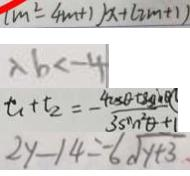Convert formula to latex. <formula><loc_0><loc_0><loc_500><loc_500>( m ^ { 2 } - 4 m + 1 ) x + ( 2 m + 1 ) 
 \lambda b < - 4 
 t _ { 1 } + t _ { 2 } = - \frac { 4 \cos \theta + 8 \sin \theta } { 3 \sin ^ { 2 } \theta + 1 } 
 2 y - 1 4 = - 6 \sqrt { y + 3 }</formula> 